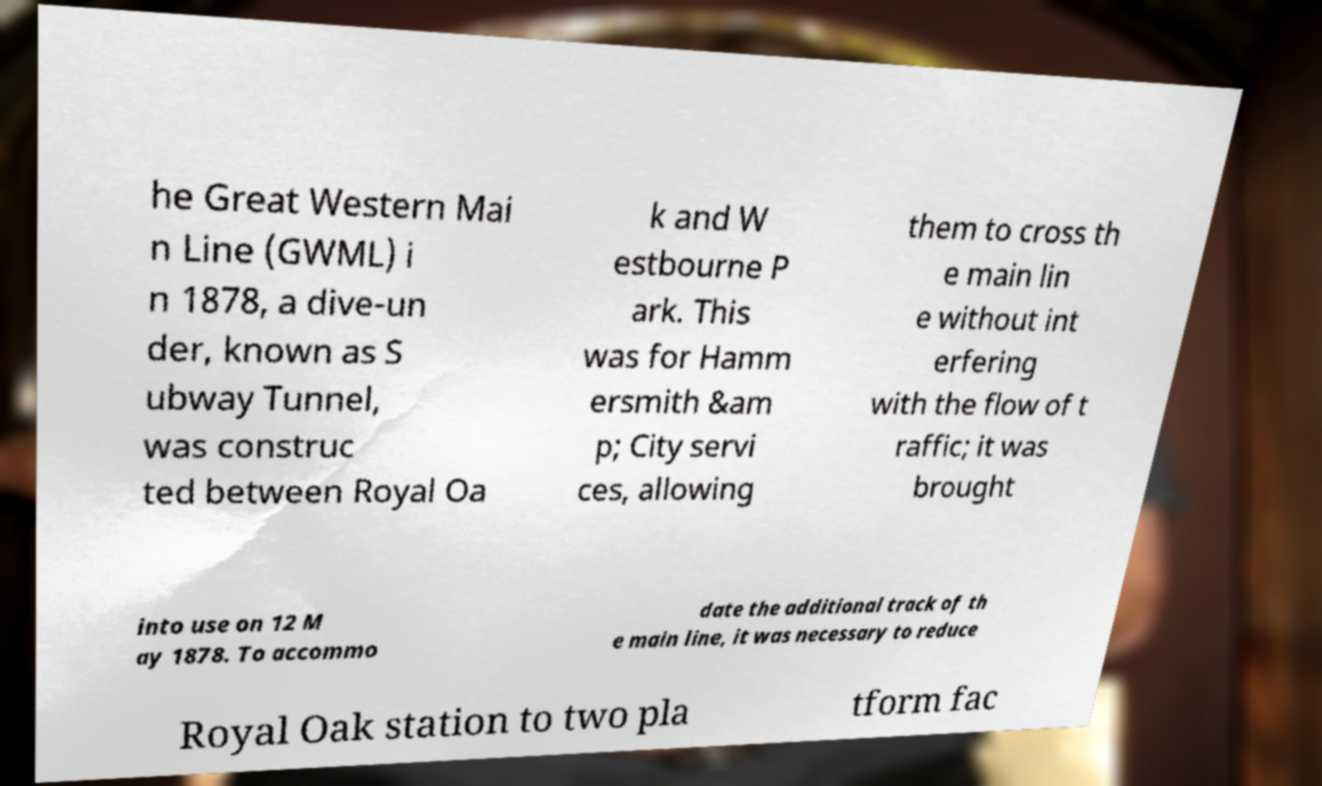Could you extract and type out the text from this image? he Great Western Mai n Line (GWML) i n 1878, a dive-un der, known as S ubway Tunnel, was construc ted between Royal Oa k and W estbourne P ark. This was for Hamm ersmith &am p; City servi ces, allowing them to cross th e main lin e without int erfering with the flow of t raffic; it was brought into use on 12 M ay 1878. To accommo date the additional track of th e main line, it was necessary to reduce Royal Oak station to two pla tform fac 